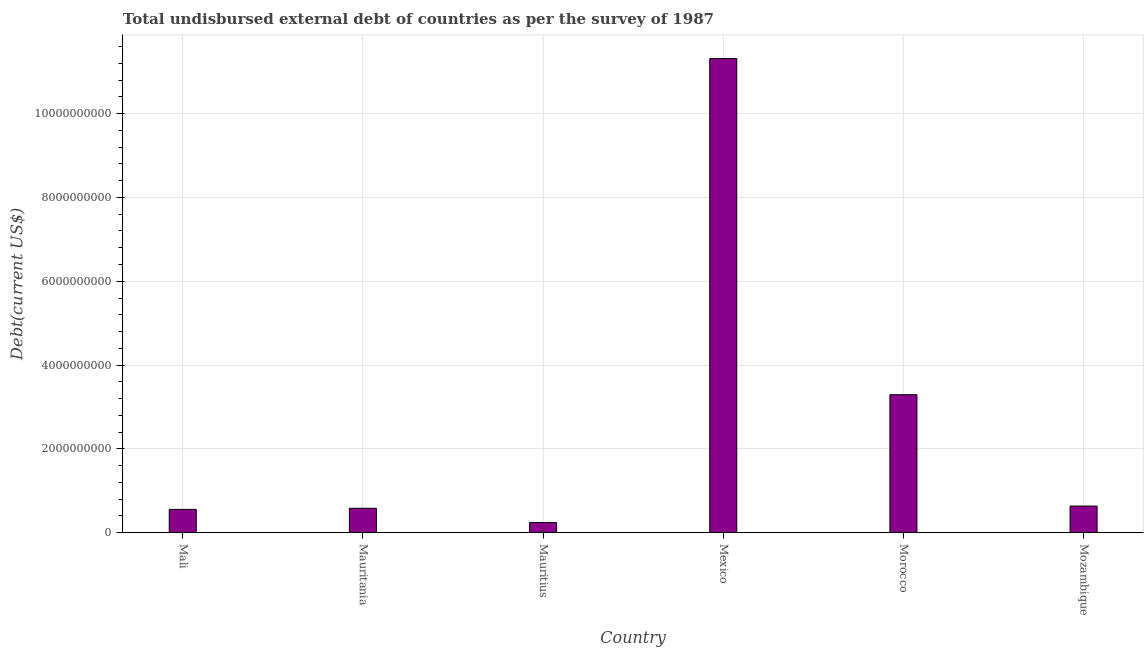Does the graph contain grids?
Provide a succinct answer. Yes. What is the title of the graph?
Your answer should be compact. Total undisbursed external debt of countries as per the survey of 1987. What is the label or title of the X-axis?
Provide a short and direct response. Country. What is the label or title of the Y-axis?
Offer a terse response. Debt(current US$). What is the total debt in Mauritania?
Your response must be concise. 5.83e+08. Across all countries, what is the maximum total debt?
Provide a short and direct response. 1.13e+1. Across all countries, what is the minimum total debt?
Give a very brief answer. 2.43e+08. In which country was the total debt maximum?
Keep it short and to the point. Mexico. In which country was the total debt minimum?
Your answer should be compact. Mauritius. What is the sum of the total debt?
Give a very brief answer. 1.66e+1. What is the difference between the total debt in Mali and Mozambique?
Provide a succinct answer. -7.97e+07. What is the average total debt per country?
Offer a terse response. 2.77e+09. What is the median total debt?
Make the answer very short. 6.10e+08. In how many countries, is the total debt greater than 3600000000 US$?
Offer a very short reply. 1. What is the ratio of the total debt in Mauritania to that in Mozambique?
Offer a very short reply. 0.92. What is the difference between the highest and the second highest total debt?
Your answer should be compact. 8.02e+09. What is the difference between the highest and the lowest total debt?
Keep it short and to the point. 1.11e+1. How many countries are there in the graph?
Offer a terse response. 6. Are the values on the major ticks of Y-axis written in scientific E-notation?
Keep it short and to the point. No. What is the Debt(current US$) of Mali?
Keep it short and to the point. 5.56e+08. What is the Debt(current US$) of Mauritania?
Ensure brevity in your answer.  5.83e+08. What is the Debt(current US$) in Mauritius?
Ensure brevity in your answer.  2.43e+08. What is the Debt(current US$) in Mexico?
Keep it short and to the point. 1.13e+1. What is the Debt(current US$) of Morocco?
Your response must be concise. 3.29e+09. What is the Debt(current US$) of Mozambique?
Provide a succinct answer. 6.36e+08. What is the difference between the Debt(current US$) in Mali and Mauritania?
Provide a succinct answer. -2.69e+07. What is the difference between the Debt(current US$) in Mali and Mauritius?
Your answer should be very brief. 3.13e+08. What is the difference between the Debt(current US$) in Mali and Mexico?
Make the answer very short. -1.08e+1. What is the difference between the Debt(current US$) in Mali and Morocco?
Offer a terse response. -2.74e+09. What is the difference between the Debt(current US$) in Mali and Mozambique?
Give a very brief answer. -7.97e+07. What is the difference between the Debt(current US$) in Mauritania and Mauritius?
Your answer should be very brief. 3.40e+08. What is the difference between the Debt(current US$) in Mauritania and Mexico?
Offer a terse response. -1.07e+1. What is the difference between the Debt(current US$) in Mauritania and Morocco?
Your answer should be very brief. -2.71e+09. What is the difference between the Debt(current US$) in Mauritania and Mozambique?
Ensure brevity in your answer.  -5.27e+07. What is the difference between the Debt(current US$) in Mauritius and Mexico?
Offer a terse response. -1.11e+1. What is the difference between the Debt(current US$) in Mauritius and Morocco?
Keep it short and to the point. -3.05e+09. What is the difference between the Debt(current US$) in Mauritius and Mozambique?
Your answer should be very brief. -3.93e+08. What is the difference between the Debt(current US$) in Mexico and Morocco?
Provide a succinct answer. 8.02e+09. What is the difference between the Debt(current US$) in Mexico and Mozambique?
Your response must be concise. 1.07e+1. What is the difference between the Debt(current US$) in Morocco and Mozambique?
Offer a terse response. 2.66e+09. What is the ratio of the Debt(current US$) in Mali to that in Mauritania?
Make the answer very short. 0.95. What is the ratio of the Debt(current US$) in Mali to that in Mauritius?
Provide a succinct answer. 2.29. What is the ratio of the Debt(current US$) in Mali to that in Mexico?
Keep it short and to the point. 0.05. What is the ratio of the Debt(current US$) in Mali to that in Morocco?
Ensure brevity in your answer.  0.17. What is the ratio of the Debt(current US$) in Mauritania to that in Mauritius?
Offer a terse response. 2.4. What is the ratio of the Debt(current US$) in Mauritania to that in Mexico?
Give a very brief answer. 0.05. What is the ratio of the Debt(current US$) in Mauritania to that in Morocco?
Make the answer very short. 0.18. What is the ratio of the Debt(current US$) in Mauritania to that in Mozambique?
Your answer should be very brief. 0.92. What is the ratio of the Debt(current US$) in Mauritius to that in Mexico?
Give a very brief answer. 0.02. What is the ratio of the Debt(current US$) in Mauritius to that in Morocco?
Give a very brief answer. 0.07. What is the ratio of the Debt(current US$) in Mauritius to that in Mozambique?
Keep it short and to the point. 0.38. What is the ratio of the Debt(current US$) in Mexico to that in Morocco?
Provide a succinct answer. 3.44. What is the ratio of the Debt(current US$) in Mexico to that in Mozambique?
Your answer should be compact. 17.79. What is the ratio of the Debt(current US$) in Morocco to that in Mozambique?
Your response must be concise. 5.18. 